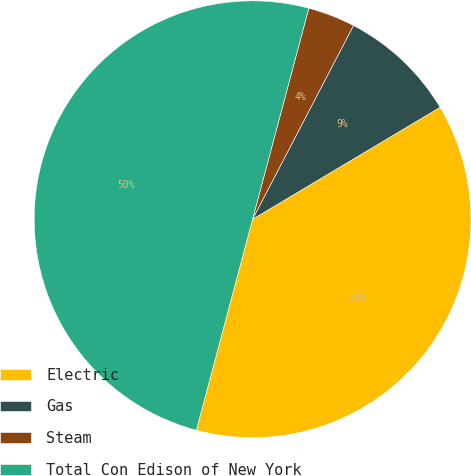Convert chart. <chart><loc_0><loc_0><loc_500><loc_500><pie_chart><fcel>Electric<fcel>Gas<fcel>Steam<fcel>Total Con Edison of New York<nl><fcel>37.71%<fcel>8.79%<fcel>3.5%<fcel>50.0%<nl></chart> 